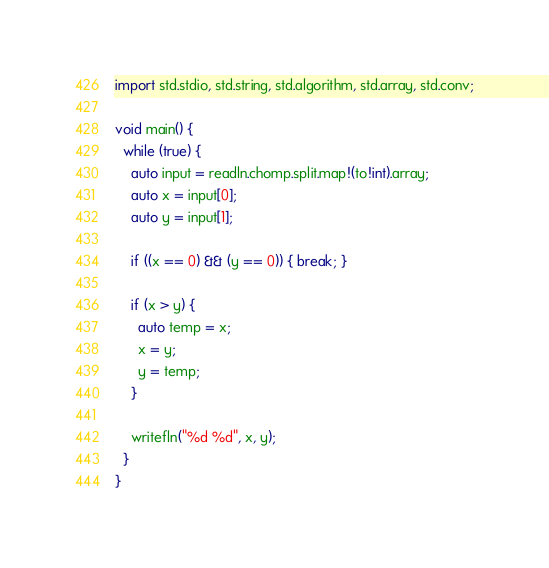Convert code to text. <code><loc_0><loc_0><loc_500><loc_500><_D_>import std.stdio, std.string, std.algorithm, std.array, std.conv;

void main() {
  while (true) {
    auto input = readln.chomp.split.map!(to!int).array;
    auto x = input[0];
    auto y = input[1];

    if ((x == 0) && (y == 0)) { break; }

    if (x > y) {
      auto temp = x;
      x = y;
      y = temp;
    }

    writefln("%d %d", x, y);
  }
}</code> 